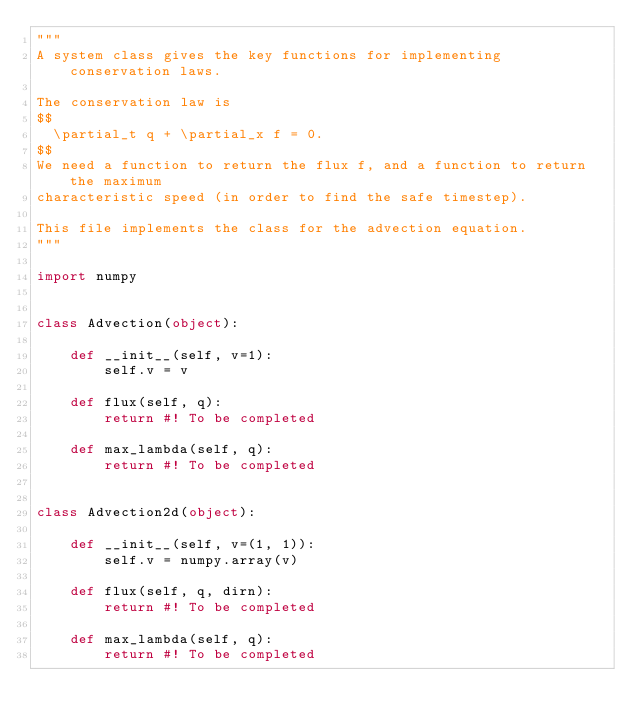Convert code to text. <code><loc_0><loc_0><loc_500><loc_500><_Python_>"""
A system class gives the key functions for implementing conservation laws.

The conservation law is
$$
  \partial_t q + \partial_x f = 0.
$$
We need a function to return the flux f, and a function to return the maximum
characteristic speed (in order to find the safe timestep).

This file implements the class for the advection equation.
"""

import numpy


class Advection(object):
    
    def __init__(self, v=1):
        self.v = v
        
    def flux(self, q):
        return #! To be completed
    
    def max_lambda(self, q):
        return #! To be completed
    

class Advection2d(object):
    
    def __init__(self, v=(1, 1)):
        self.v = numpy.array(v)
        
    def flux(self, q, dirn):
        return #! To be completed
    
    def max_lambda(self, q):
        return #! To be completed
</code> 